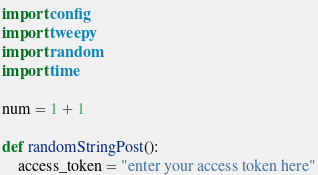<code> <loc_0><loc_0><loc_500><loc_500><_Python_>import config
import tweepy
import random
import time

num = 1 + 1

def randomStringPost():
    access_token = "enter your access token here"</code> 